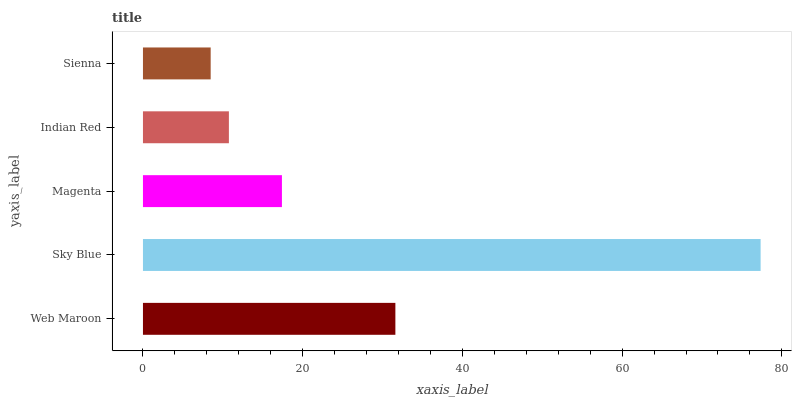Is Sienna the minimum?
Answer yes or no. Yes. Is Sky Blue the maximum?
Answer yes or no. Yes. Is Magenta the minimum?
Answer yes or no. No. Is Magenta the maximum?
Answer yes or no. No. Is Sky Blue greater than Magenta?
Answer yes or no. Yes. Is Magenta less than Sky Blue?
Answer yes or no. Yes. Is Magenta greater than Sky Blue?
Answer yes or no. No. Is Sky Blue less than Magenta?
Answer yes or no. No. Is Magenta the high median?
Answer yes or no. Yes. Is Magenta the low median?
Answer yes or no. Yes. Is Web Maroon the high median?
Answer yes or no. No. Is Sky Blue the low median?
Answer yes or no. No. 